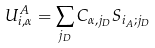<formula> <loc_0><loc_0><loc_500><loc_500>U ^ { A } _ { i , \alpha } = \sum _ { j _ { D } } C _ { \alpha , j _ { D } } S _ { i _ { A } ; j _ { D } }</formula> 